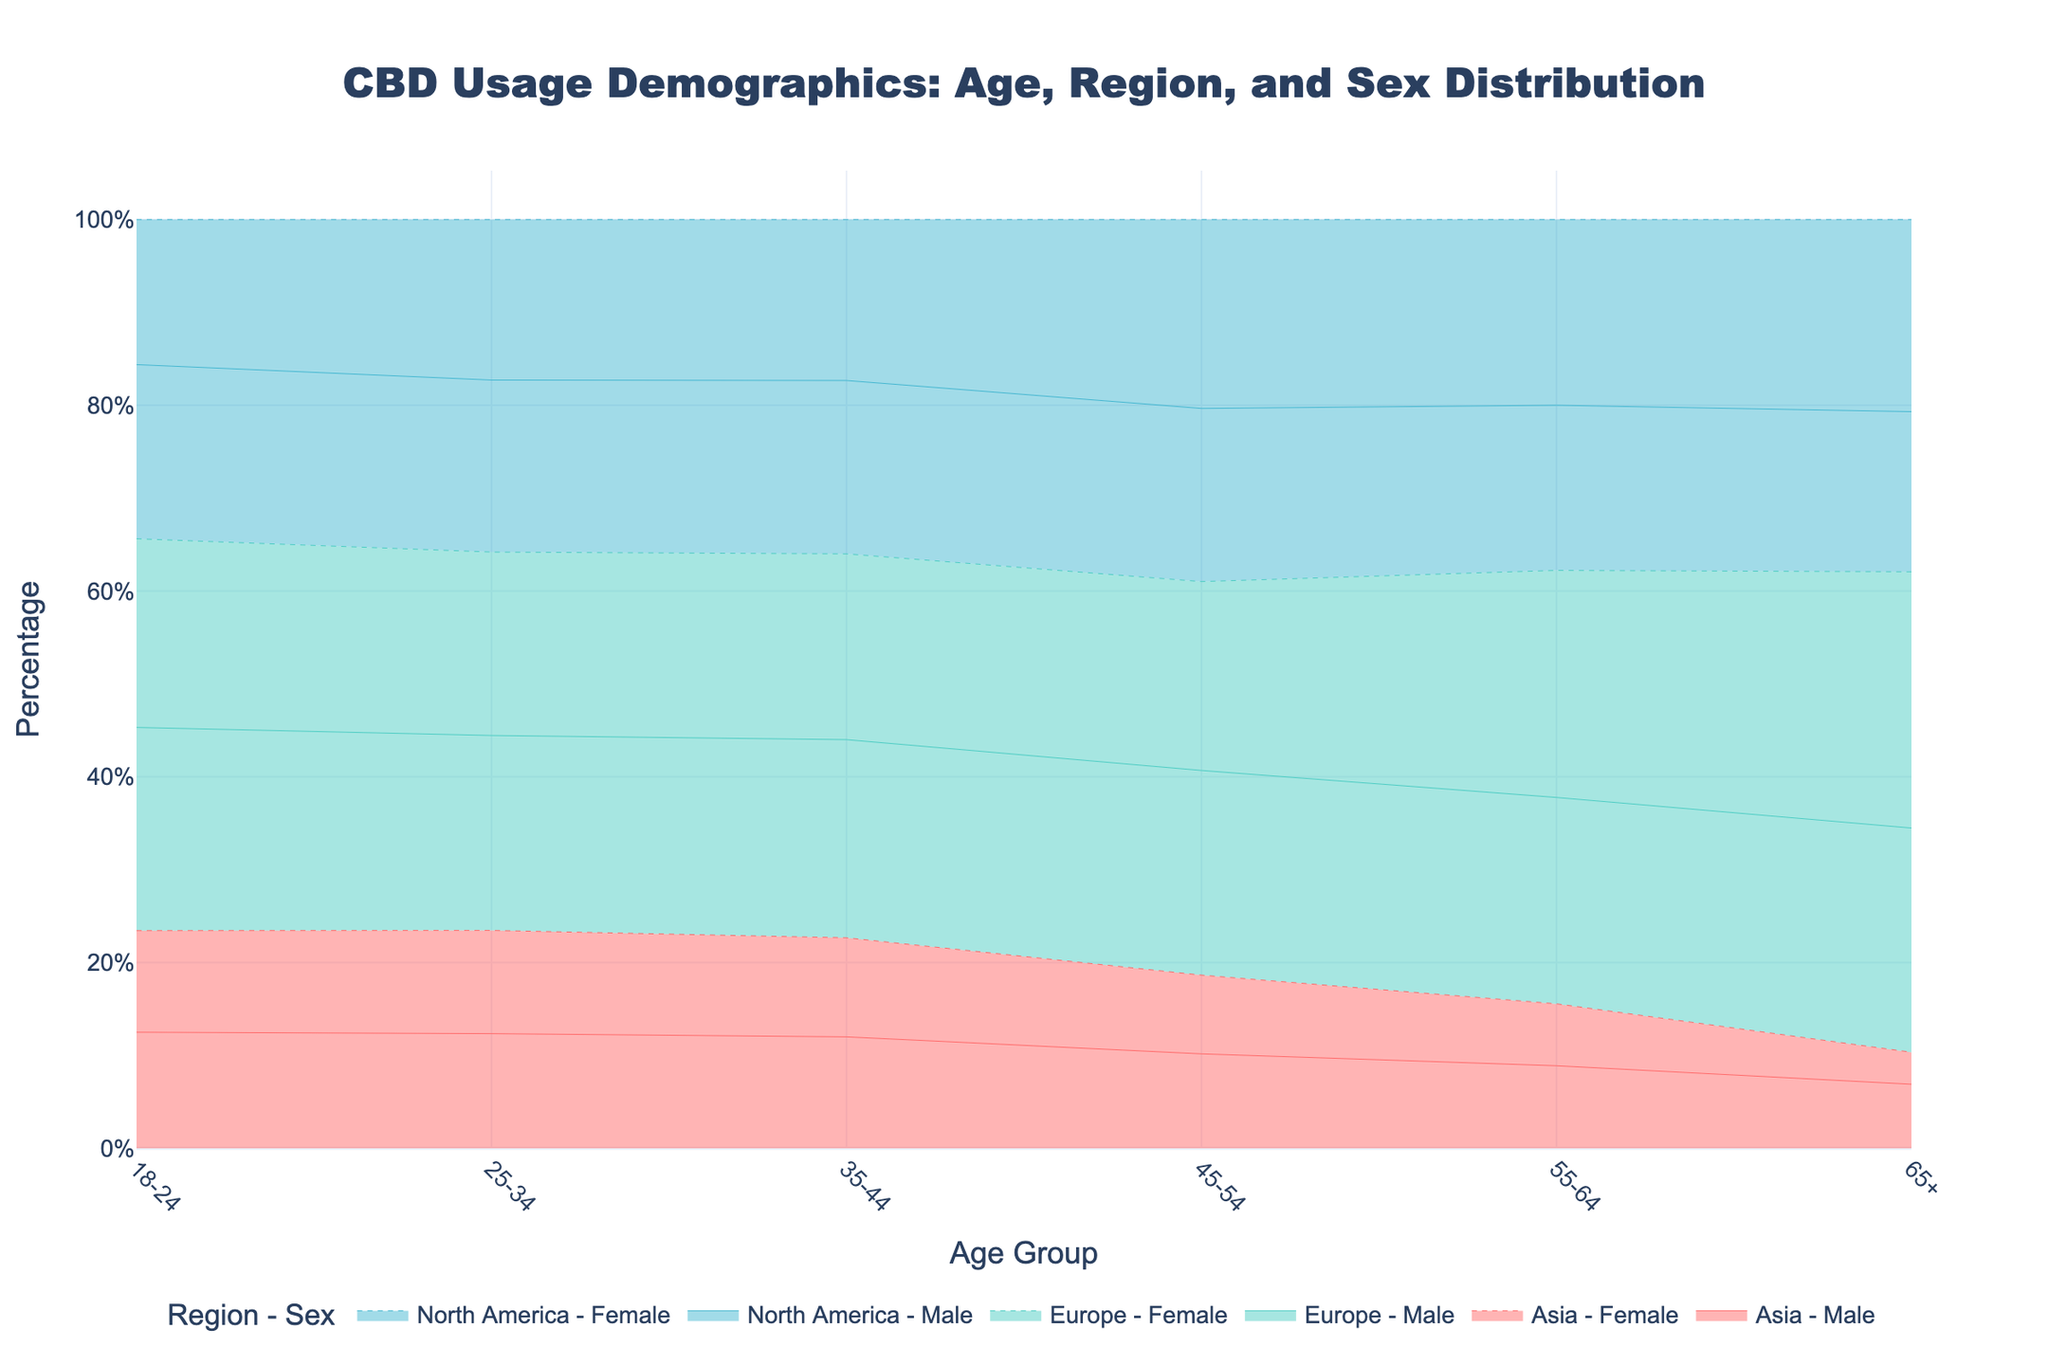How is CBD usage distributed between males and females in the 25-34 age group across regions? Check the colors and stacking for the 25-34 age group in the chart. Compare the height of male and female segments in North America, Europe, and Asia.
Answer: Males in Europe Which region shows the highest CBD usage among the 18-24 age group? Look at the topmost segments for the 18-24 age group in the chart. Identify which region has the greatest combined male and female usage.
Answer: Europe In which age group is the difference in CBD usage between males and females the smallest in North America? Inspect the height difference between male and female segments in each age group for North America. The smallest difference corresponds to the smallest gap between the two segments.
Answer: 45-54 Comparing Asia and Europe, which region has a higher percentage of female CBD users in the 35-44 age group? Compare the heights of the female segments in the 35-44 age group for both Asia and Europe. The taller segment indicates higher usage.
Answer: Europe What is the overall trend of CBD usage as age increases in North America? Observe the combined height of male and female segments for each age group in North America. Note how the total height changes with increasing age.
Answer: Decreases What is the percentage point decrease in male CBD usage from the 25-34 age group to the 35-44 age group in Asia? Identify the height of the male segment in both age groups in Asia and calculate the difference.
Answer: 1 percentage point Which sex shows a higher CBD usage in the 55-64 age group in Europe? Compare the height of male and female segments within the 55-64 age group for Europe. Identify the taller segment.
Answer: Female What's the combined percentage of CBD usage for females in the 18-24 and 25-34 age group in North America? Add the heights of female segments in the 18-24 and 25-34 age groups in North America. Perform the addition to find the combined usage.
Answer: 24% In the 65+ age group, which region has the lowest male CBD usage? Review the male segments in the 65+ age group across all regions. Identify the region with the lowest segment height.
Answer: Asia 